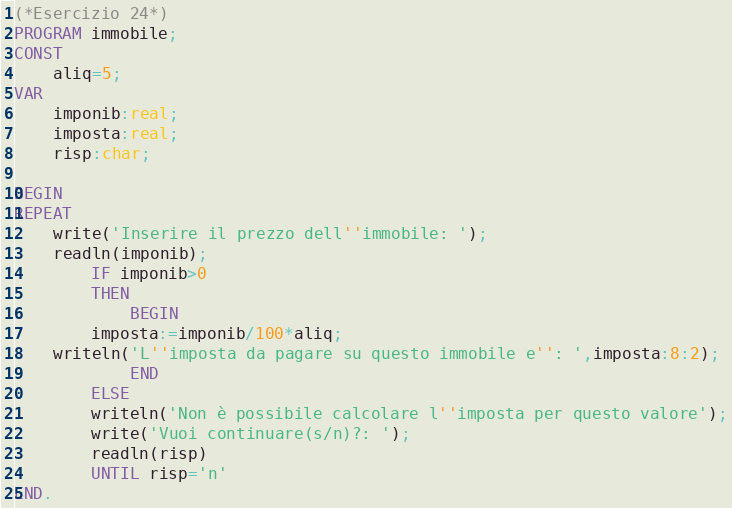<code> <loc_0><loc_0><loc_500><loc_500><_Pascal_>(*Esercizio 24*)
PROGRAM immobile;
CONST
	aliq=5;
VAR
	imponib:real;
	imposta:real;
	risp:char;
	
BEGIN
REPEAT
	write('Inserire il prezzo dell''immobile: ');
	readln(imponib);
		IF imponib>0
		THEN
			BEGIN
		imposta:=imponib/100*aliq;
	writeln('L''imposta da pagare su questo immobile e'': ',imposta:8:2);
			END
		ELSE
		writeln('Non è possibile calcolare l''imposta per questo valore');
		write('Vuoi continuare(s/n)?: ');
		readln(risp)
		UNTIL risp='n'
END.</code> 